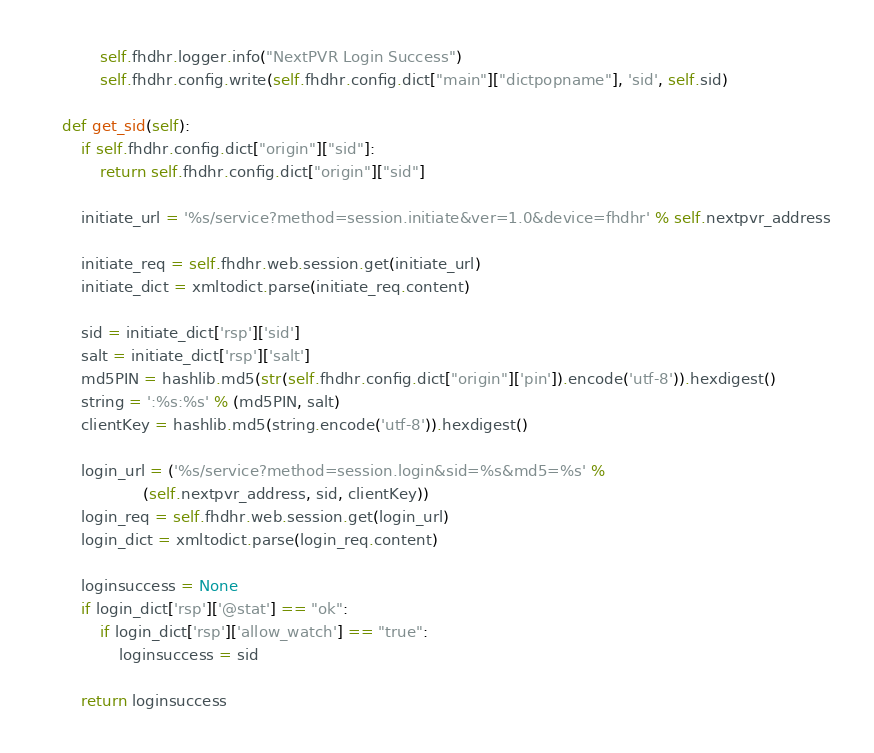Convert code to text. <code><loc_0><loc_0><loc_500><loc_500><_Python_>            self.fhdhr.logger.info("NextPVR Login Success")
            self.fhdhr.config.write(self.fhdhr.config.dict["main"]["dictpopname"], 'sid', self.sid)

    def get_sid(self):
        if self.fhdhr.config.dict["origin"]["sid"]:
            return self.fhdhr.config.dict["origin"]["sid"]

        initiate_url = '%s/service?method=session.initiate&ver=1.0&device=fhdhr' % self.nextpvr_address

        initiate_req = self.fhdhr.web.session.get(initiate_url)
        initiate_dict = xmltodict.parse(initiate_req.content)

        sid = initiate_dict['rsp']['sid']
        salt = initiate_dict['rsp']['salt']
        md5PIN = hashlib.md5(str(self.fhdhr.config.dict["origin"]['pin']).encode('utf-8')).hexdigest()
        string = ':%s:%s' % (md5PIN, salt)
        clientKey = hashlib.md5(string.encode('utf-8')).hexdigest()

        login_url = ('%s/service?method=session.login&sid=%s&md5=%s' %
                     (self.nextpvr_address, sid, clientKey))
        login_req = self.fhdhr.web.session.get(login_url)
        login_dict = xmltodict.parse(login_req.content)

        loginsuccess = None
        if login_dict['rsp']['@stat'] == "ok":
            if login_dict['rsp']['allow_watch'] == "true":
                loginsuccess = sid

        return loginsuccess
</code> 